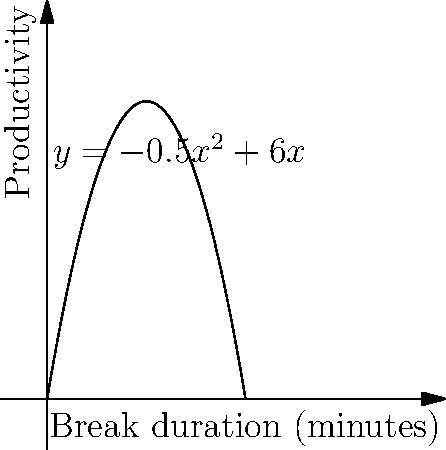As a health-conscious coworker promoting workplace well-being, you've researched the relationship between break duration and productivity. The graph shows productivity as a function of break duration, represented by the equation $y = -0.5x^2 + 6x$, where $x$ is the break duration in minutes and $y$ is the productivity score. What is the optimal break duration to maximize productivity, and what is the maximum productivity score? To find the optimal break duration and maximum productivity, we need to follow these steps:

1) The function is a quadratic equation in the form $f(x) = -0.5x^2 + 6x$.

2) To find the maximum point, we need to find the vertex of the parabola. For a quadratic function $f(x) = ax^2 + bx + c$, the x-coordinate of the vertex is given by $x = -\frac{b}{2a}$.

3) In our case, $a = -0.5$ and $b = 6$. So:

   $x = -\frac{6}{2(-0.5)} = -\frac{6}{-1} = 6$

4) This means the optimal break duration is 6 minutes.

5) To find the maximum productivity score, we substitute $x = 6$ into the original equation:

   $y = -0.5(6)^2 + 6(6)$
   $y = -0.5(36) + 36$
   $y = -18 + 36 = 18$

Therefore, the maximum productivity score is 18.
Answer: Optimal break duration: 6 minutes; Maximum productivity score: 18 